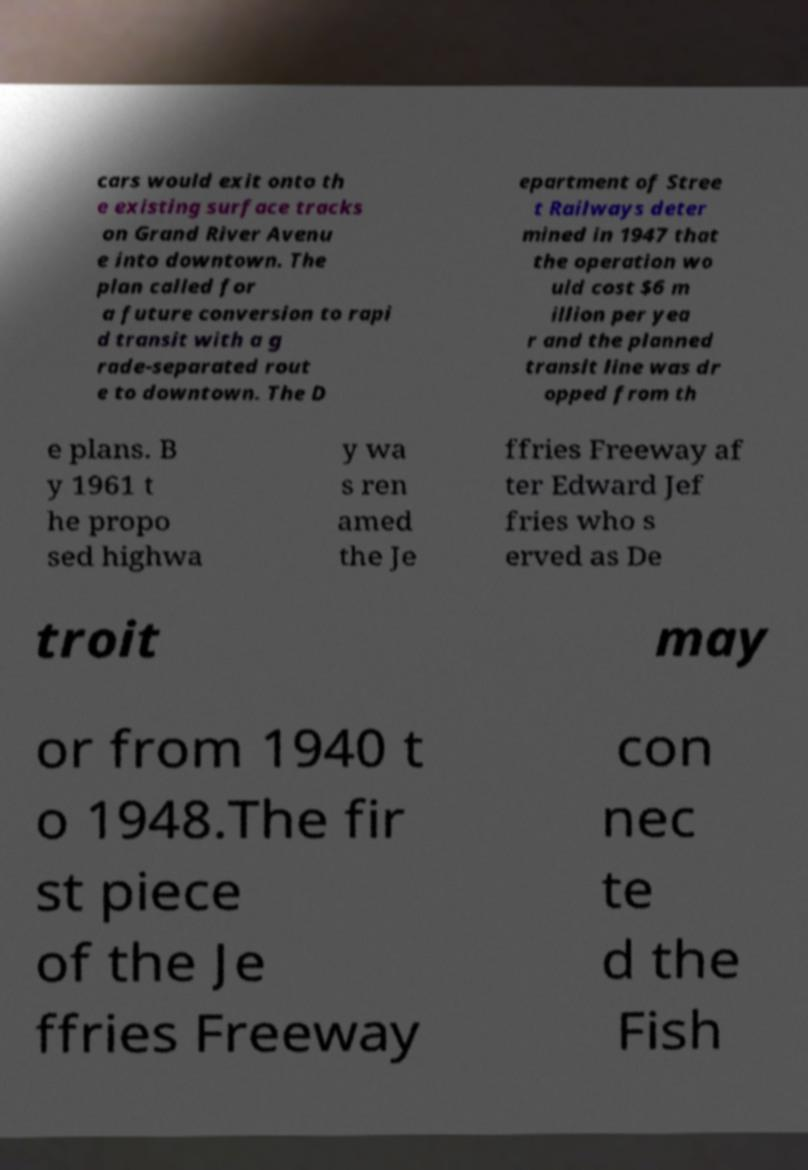Can you read and provide the text displayed in the image?This photo seems to have some interesting text. Can you extract and type it out for me? cars would exit onto th e existing surface tracks on Grand River Avenu e into downtown. The plan called for a future conversion to rapi d transit with a g rade-separated rout e to downtown. The D epartment of Stree t Railways deter mined in 1947 that the operation wo uld cost $6 m illion per yea r and the planned transit line was dr opped from th e plans. B y 1961 t he propo sed highwa y wa s ren amed the Je ffries Freeway af ter Edward Jef fries who s erved as De troit may or from 1940 t o 1948.The fir st piece of the Je ffries Freeway con nec te d the Fish 